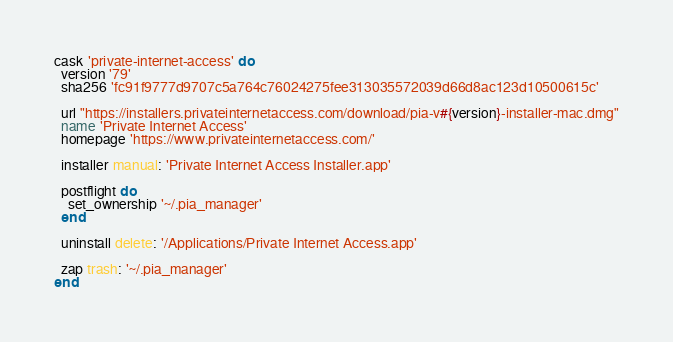Convert code to text. <code><loc_0><loc_0><loc_500><loc_500><_Ruby_>cask 'private-internet-access' do
  version '79'
  sha256 'fc91f9777d9707c5a764c76024275fee313035572039d66d8ac123d10500615c'

  url "https://installers.privateinternetaccess.com/download/pia-v#{version}-installer-mac.dmg"
  name 'Private Internet Access'
  homepage 'https://www.privateinternetaccess.com/'

  installer manual: 'Private Internet Access Installer.app'

  postflight do
    set_ownership '~/.pia_manager'
  end

  uninstall delete: '/Applications/Private Internet Access.app'

  zap trash: '~/.pia_manager'
end
</code> 